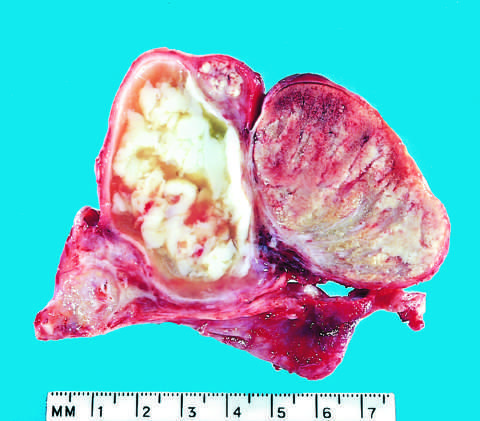s bowing of legs caused by gonococcal infection?
Answer the question using a single word or phrase. No 